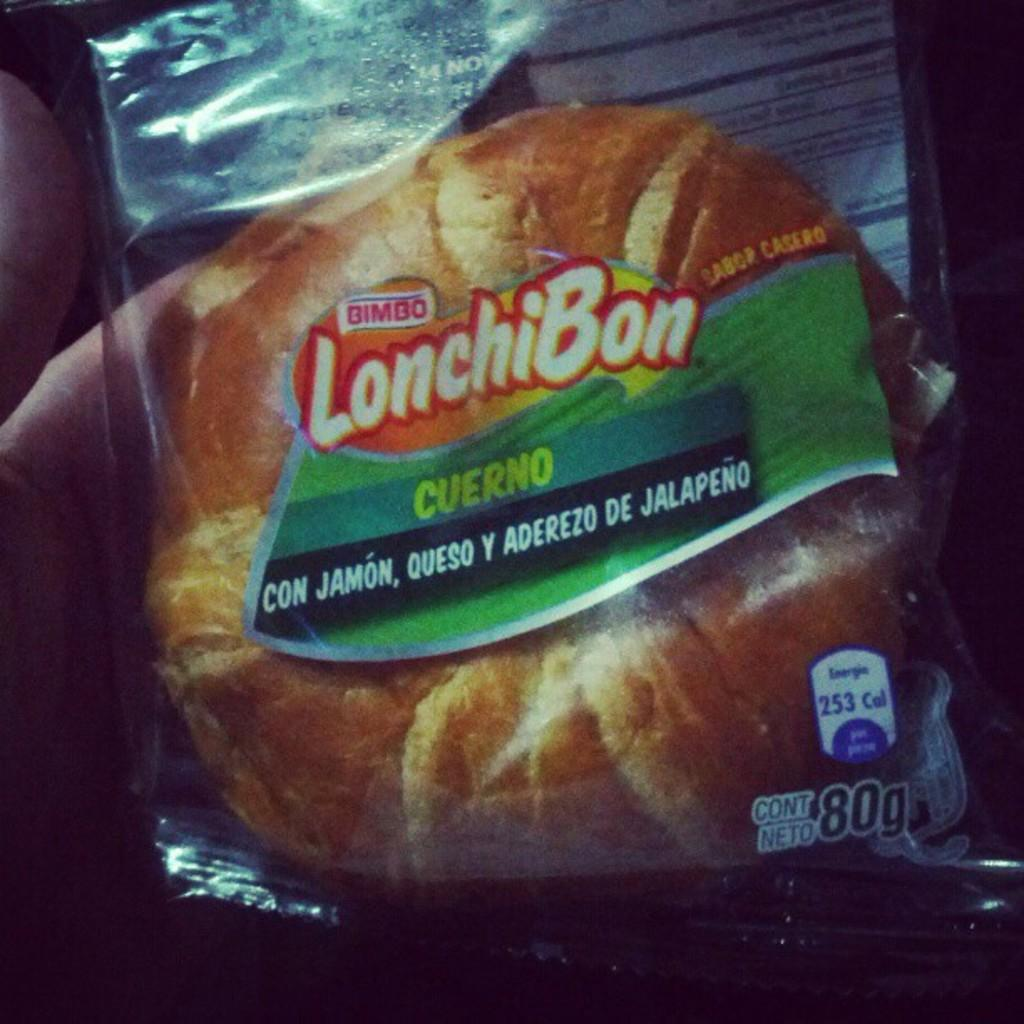What is the main subject of the image? There is a person in the image. What is the person holding in the image? The person is holding a bread packet. What can be seen on the bread packet? There is text written on the bread packet. How many goldfish are swimming in the image? There are no goldfish present in the image. What is the temperature of the quiet room in the image? There is no mention of a quiet room or temperature in the image. 